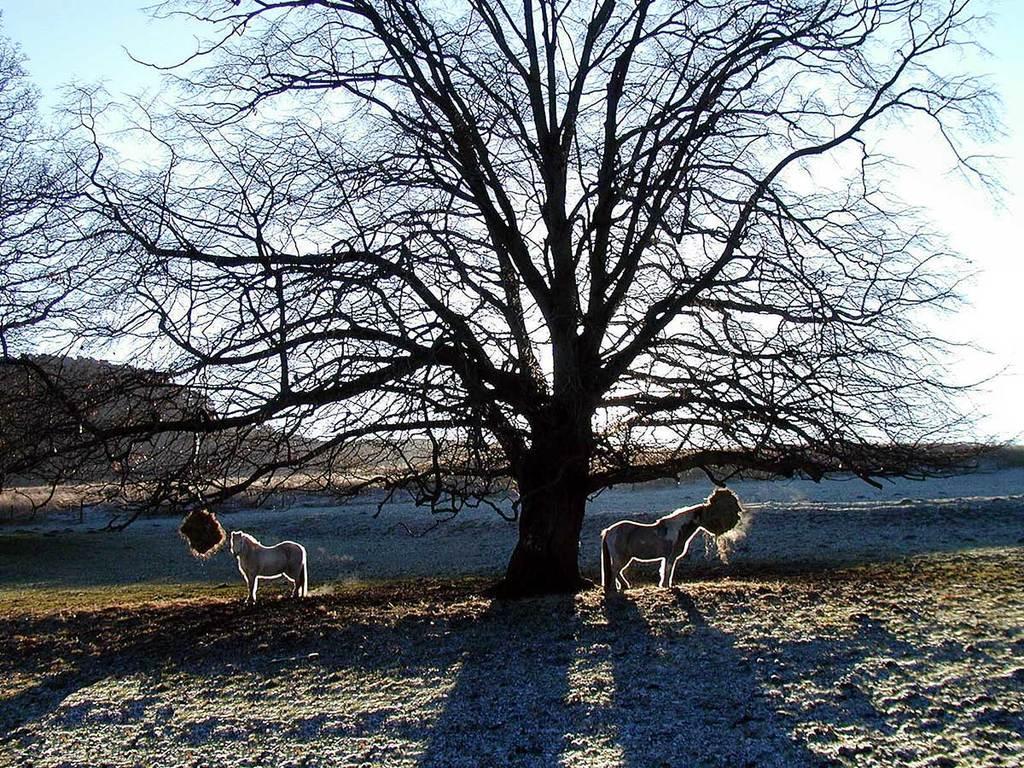How would you summarize this image in a sentence or two? In this picture I can observe two horses standing on the land. I can observe dried tree in the middle of this picture. In the background there is a hill and a sky. 